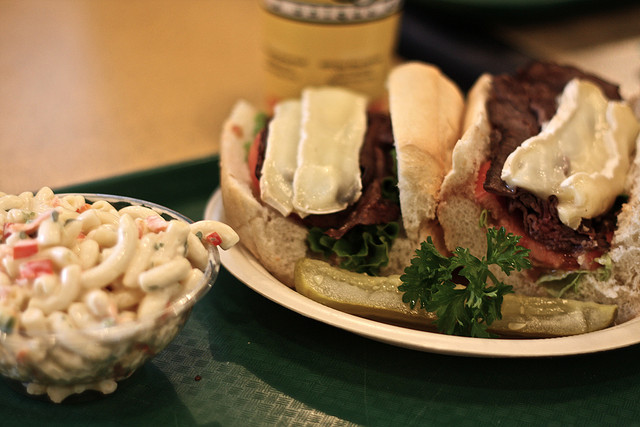<image>How many calories is in the food? I don't know how many calories are in the food. The amount could range anywhere from 200 to 2500. How many calories is in the food? I'm not sure how many calories are in the food. It can be around 400, 800, 300 or 200. 